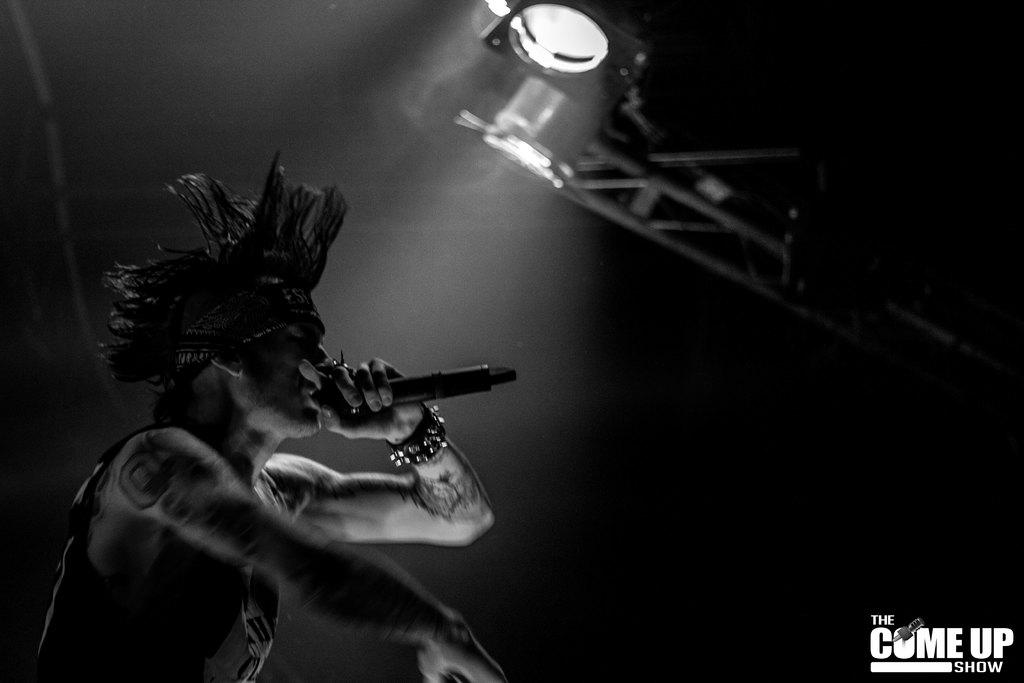What is the person in the image holding? The person is holding a mic in the image. What can be seen at the top of the image? There is a light with a stand at the top of the image. What is present in the bottom right corner of the image? There is some text visible in the bottom right corner of the image. What type of weather can be seen in the image? There is no weather visible in the image; it is an indoor scene. 